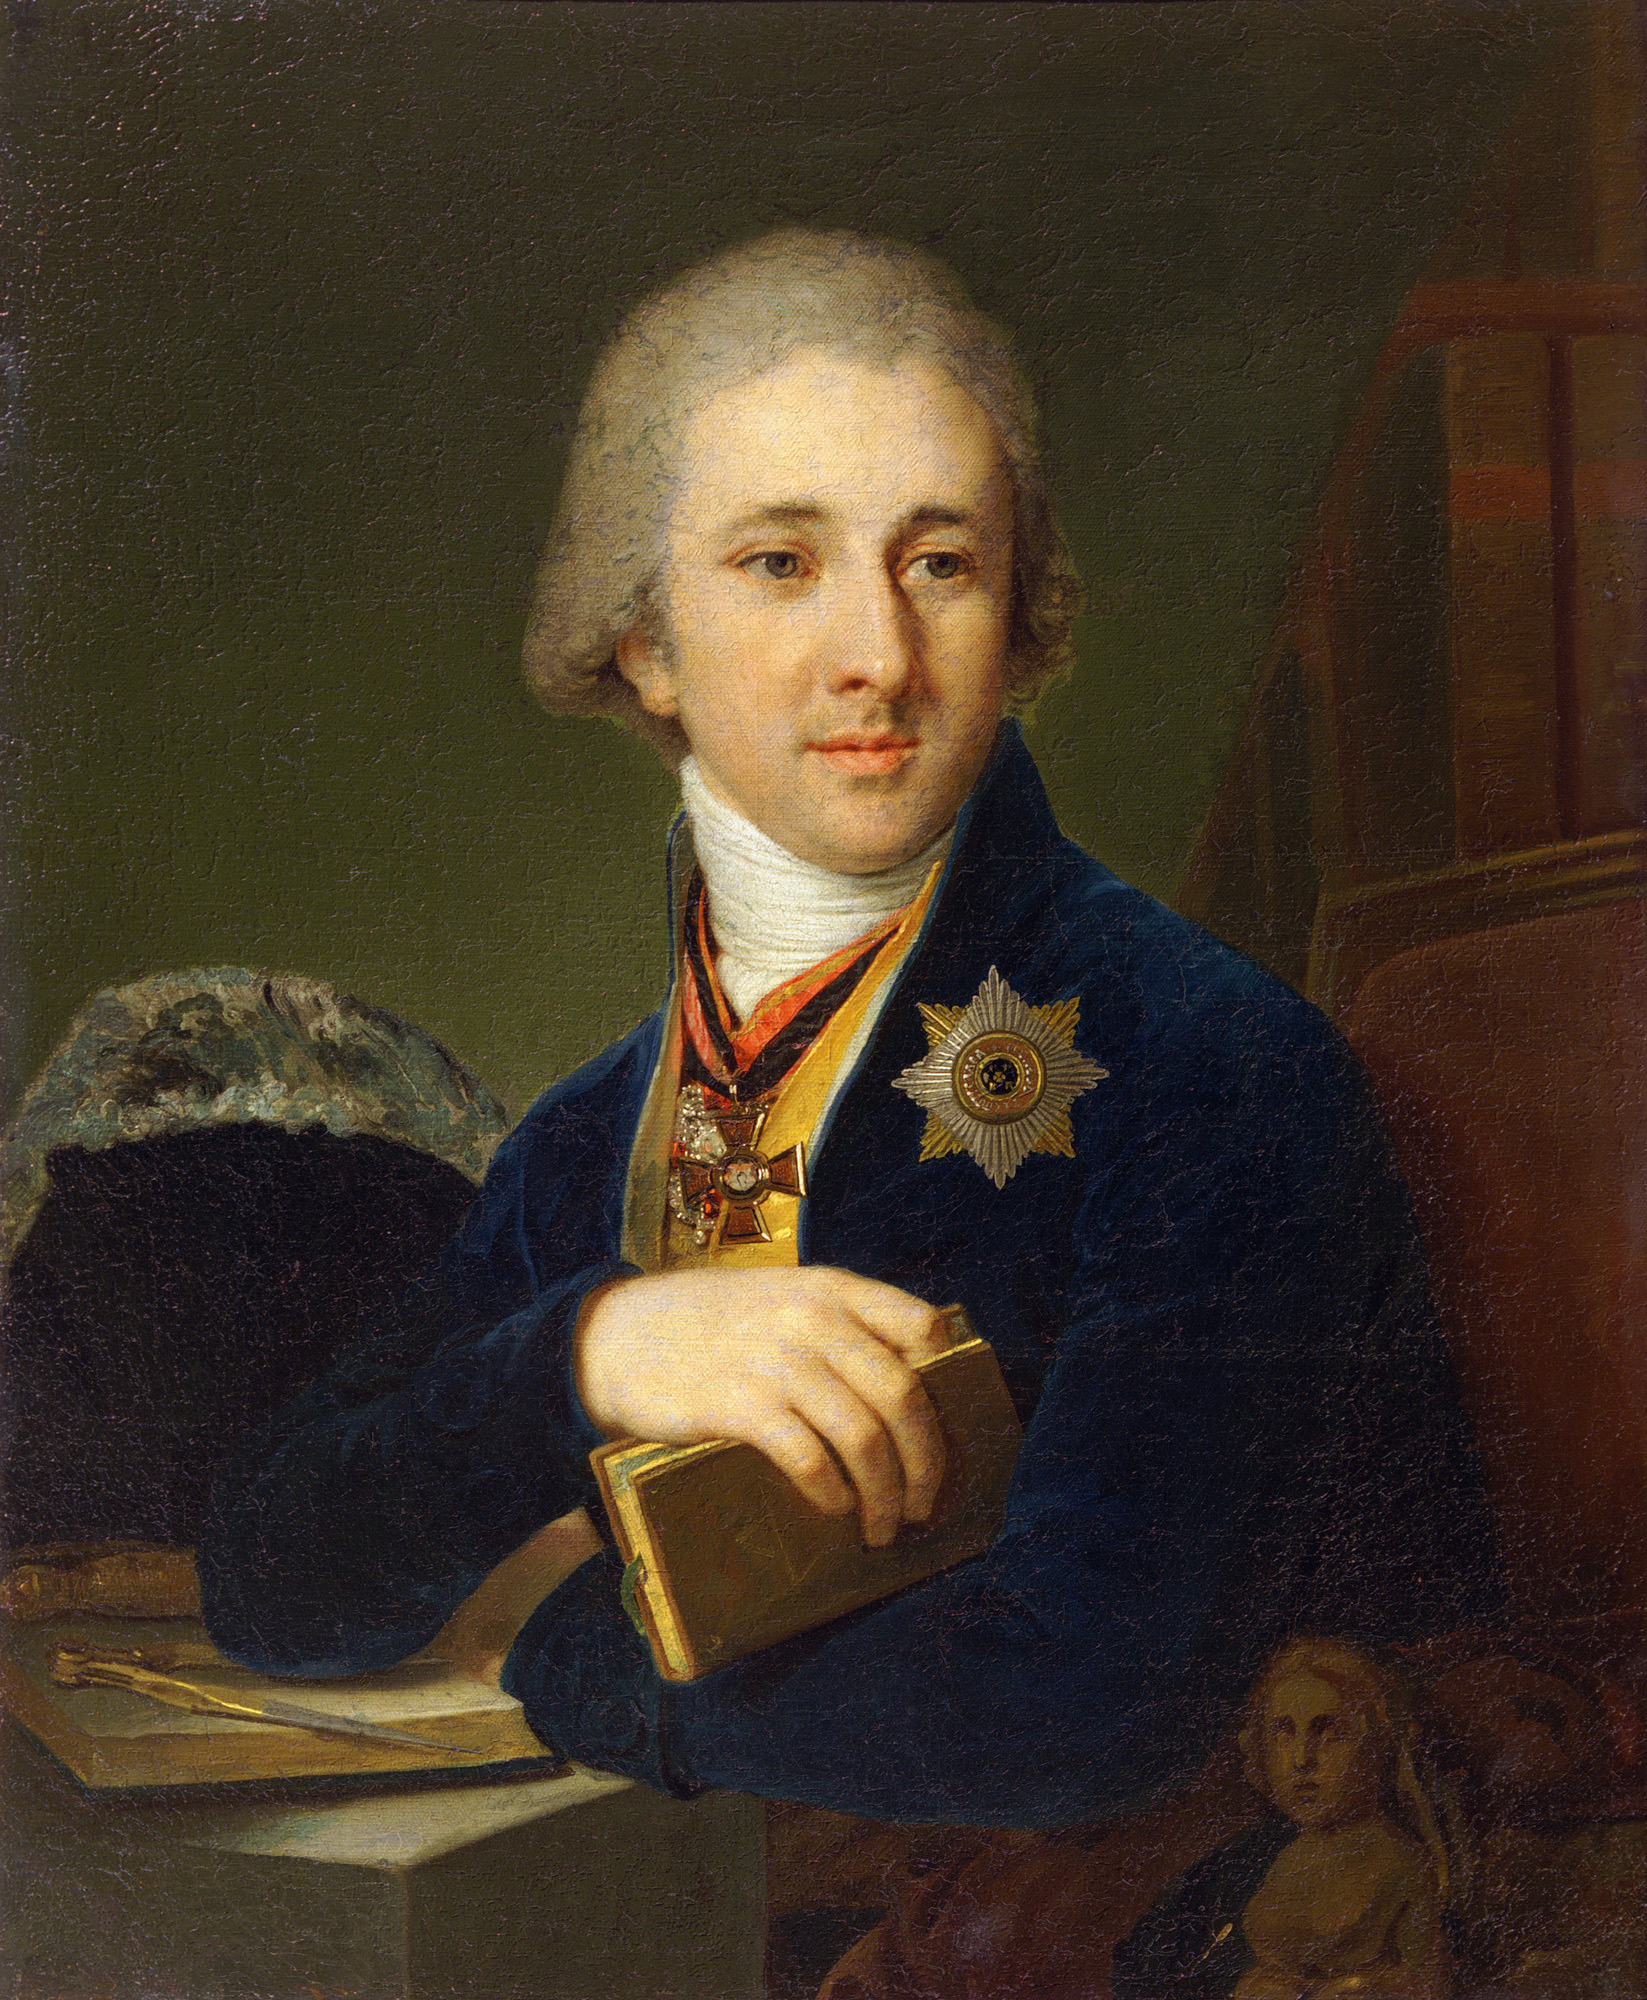Imagine this painting was part of a scene in a historical fantasy novel. What role would this character play? In a historical fantasy novel, this character could be a wise and revered scholar-mage, whose knowledge spans both the arcane and scientific realms. Holding a cryptic tome imbued with ancient wisdom, he serves as an advisor to the king, guiding decisions that balance magical lore with enlightened governance. His medals signify recognition not only from the earthly realm but also from mystical orders honoring his mastery of spells and his contributions to maintaining harmony between magic and the natural world. 